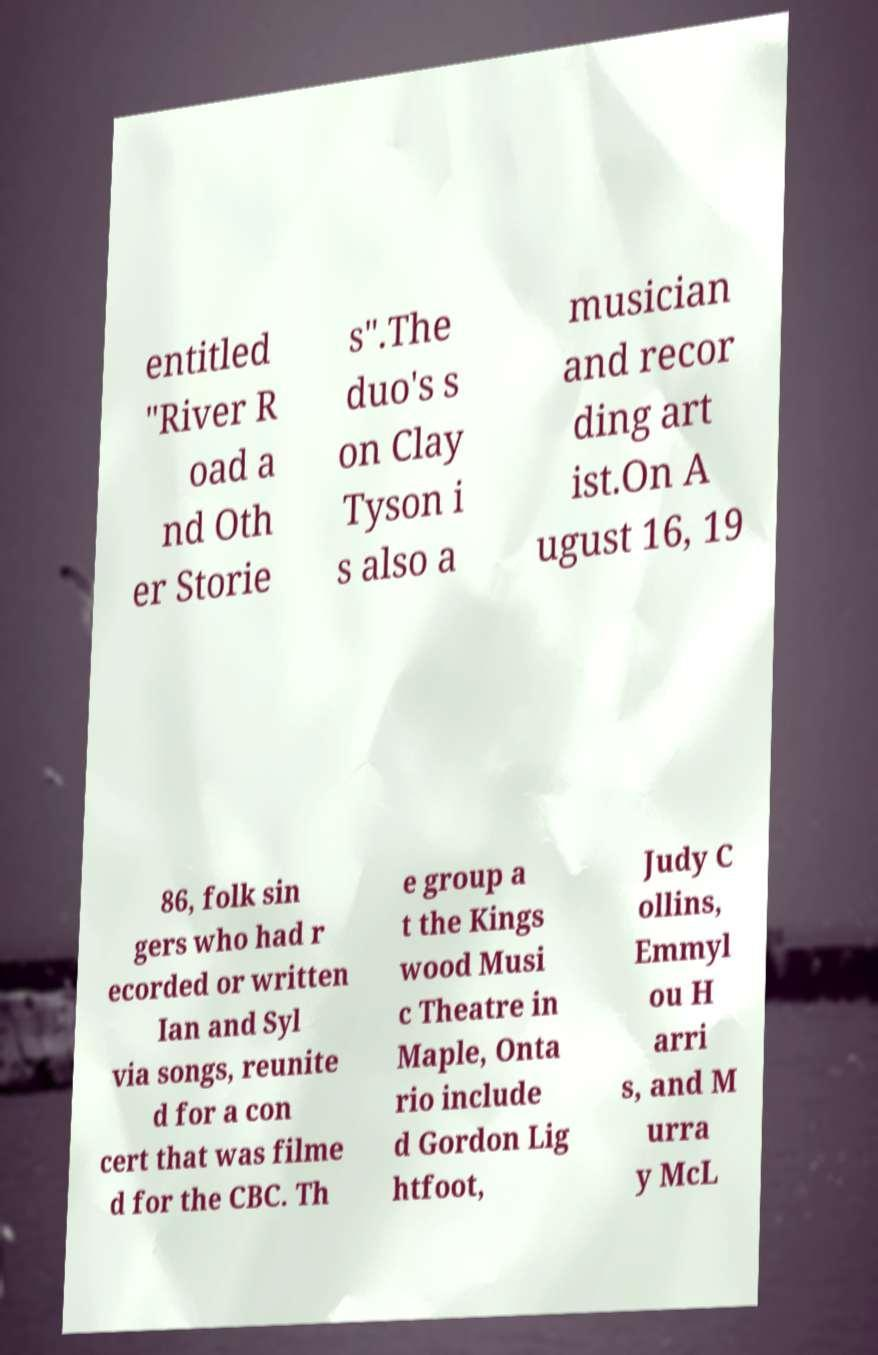Can you read and provide the text displayed in the image?This photo seems to have some interesting text. Can you extract and type it out for me? entitled "River R oad a nd Oth er Storie s".The duo's s on Clay Tyson i s also a musician and recor ding art ist.On A ugust 16, 19 86, folk sin gers who had r ecorded or written Ian and Syl via songs, reunite d for a con cert that was filme d for the CBC. Th e group a t the Kings wood Musi c Theatre in Maple, Onta rio include d Gordon Lig htfoot, Judy C ollins, Emmyl ou H arri s, and M urra y McL 